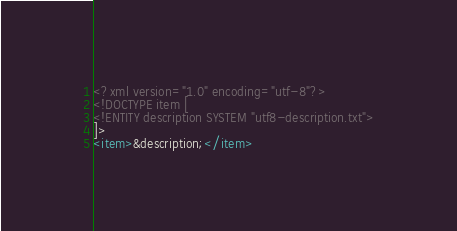Convert code to text. <code><loc_0><loc_0><loc_500><loc_500><_XML_><?xml version="1.0" encoding="utf-8"?>
<!DOCTYPE item [
<!ENTITY description SYSTEM "utf8-description.txt">
]>
<item>&description;</item>
</code> 